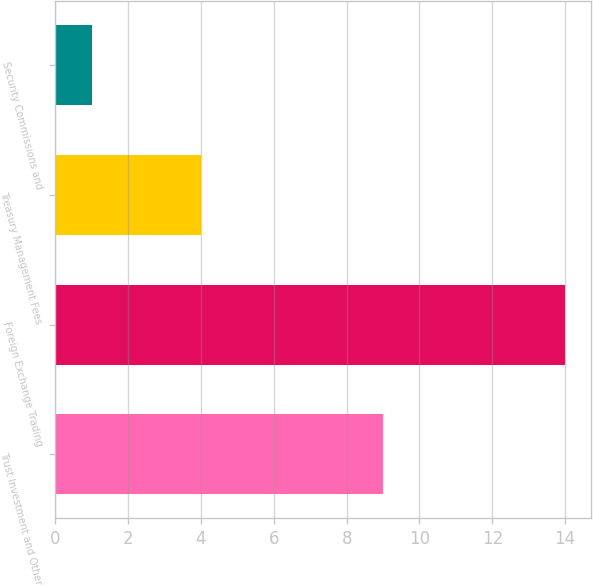<chart> <loc_0><loc_0><loc_500><loc_500><bar_chart><fcel>Trust Investment and Other<fcel>Foreign Exchange Trading<fcel>Treasury Management Fees<fcel>Security Commissions and<nl><fcel>9<fcel>14<fcel>4<fcel>1<nl></chart> 